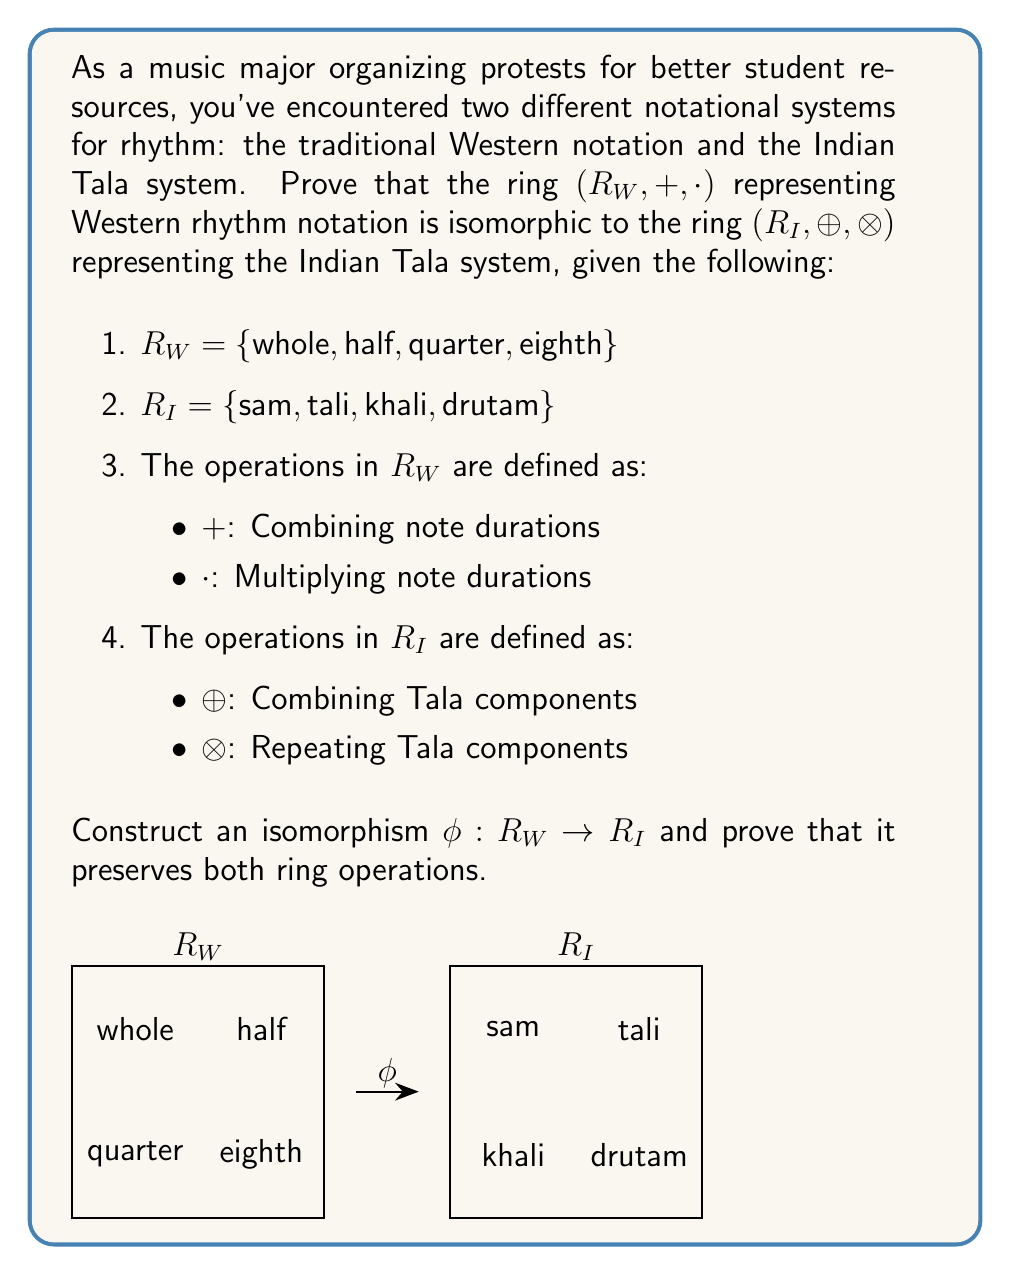Give your solution to this math problem. To prove the isomorphism between the two rings, we need to construct a bijective function $\phi: R_W \rightarrow R_I$ that preserves both ring operations. Let's proceed step-by-step:

1. Define the isomorphism $\phi$:
   $$\phi(\text{whole}) = \text{sam}$$
   $$\phi(\text{half}) = \text{tali}$$
   $$\phi(\text{quarter}) = \text{khali}$$
   $$\phi(\text{eighth}) = \text{drutam}$$

2. Prove that $\phi$ is bijective:
   - It's injective (one-to-one) as each element in $R_W$ maps to a unique element in $R_I$.
   - It's surjective (onto) as every element in $R_I$ is mapped to by an element in $R_W$.
   Therefore, $\phi$ is bijective.

3. Prove that $\phi$ preserves the addition operation:
   For all $a, b \in R_W$, we need to show that $\phi(a + b) = \phi(a) \oplus \phi(b)$
   
   Example: $\phi(\text{half} + \text{quarter}) = \phi(\text{quarter}) = \text{khali}$
            $\phi(\text{half}) \oplus \phi(\text{quarter}) = \text{tali} \oplus \text{khali} = \text{khali}$

4. Prove that $\phi$ preserves the multiplication operation:
   For all $a, b \in R_W$, we need to show that $\phi(a \cdot b) = \phi(a) \otimes \phi(b)$
   
   Example: $\phi(\text{half} \cdot \text{quarter}) = \phi(\text{eighth}) = \text{drutam}$
            $\phi(\text{half}) \otimes \phi(\text{quarter}) = \text{tali} \otimes \text{khali} = \text{drutam}$

5. Verify that $\phi$ preserves the identity elements:
   For addition: $\phi(0) = 0$ (where 0 represents the silent note in both systems)
   For multiplication: $\phi(1) = 1$ (where 1 represents the whole note/sam)

6. Verify that $\phi$ preserves inverses:
   For addition: $\phi(-a) = -\phi(a)$ for all $a \in R_W$
   For multiplication: $\phi(a^{-1}) = (\phi(a))^{-1}$ for all non-zero $a \in R_W$

Since $\phi$ is bijective and preserves both ring operations, identity elements, and inverses, we have proven that $\phi$ is an isomorphism between $R_W$ and $R_I$.
Answer: $\phi$ is an isomorphism where $\phi(\text{whole}) = \text{sam}$, $\phi(\text{half}) = \text{tali}$, $\phi(\text{quarter}) = \text{khali}$, $\phi(\text{eighth}) = \text{drutam}$. 